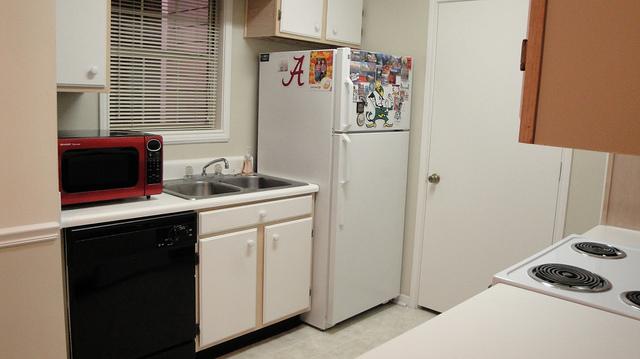Is there an electric outlet in the picture?
Short answer required. No. What color is the microwave?
Short answer required. Red. How many different types of door are visible?
Answer briefly. 5. How many items are on the fridge?
Answer briefly. Many. How do the windows open?
Short answer required. Slide. What provides heat for the stove top:  electricity or natural gas?
Give a very brief answer. Electricity. Does the fridge match the counters?
Give a very brief answer. Yes. Which room is this?
Keep it brief. Kitchen. Is the microwave open or closed?
Answer briefly. Closed. What is on top of the small appliance?
Answer briefly. Nothing. What is covering the window?
Be succinct. Blinds. 